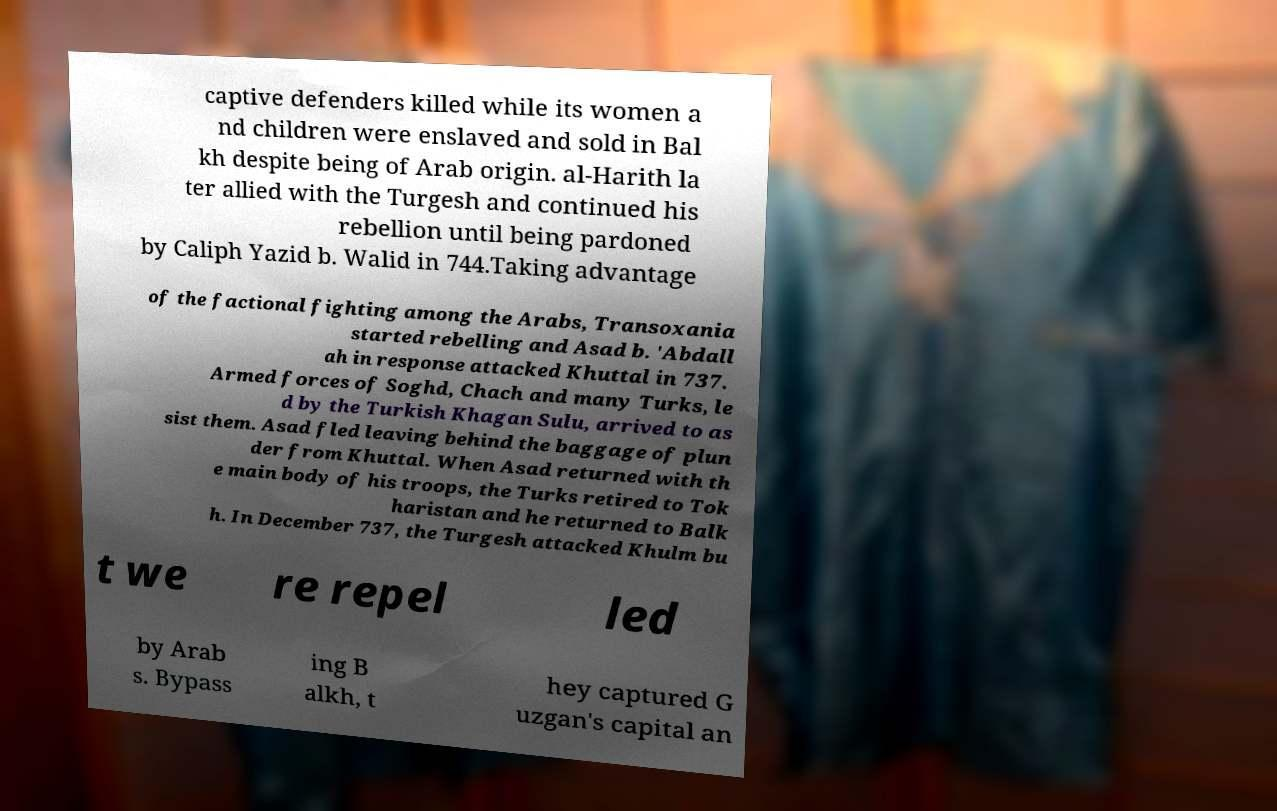There's text embedded in this image that I need extracted. Can you transcribe it verbatim? captive defenders killed while its women a nd children were enslaved and sold in Bal kh despite being of Arab origin. al-Harith la ter allied with the Turgesh and continued his rebellion until being pardoned by Caliph Yazid b. Walid in 744.Taking advantage of the factional fighting among the Arabs, Transoxania started rebelling and Asad b. 'Abdall ah in response attacked Khuttal in 737. Armed forces of Soghd, Chach and many Turks, le d by the Turkish Khagan Sulu, arrived to as sist them. Asad fled leaving behind the baggage of plun der from Khuttal. When Asad returned with th e main body of his troops, the Turks retired to Tok haristan and he returned to Balk h. In December 737, the Turgesh attacked Khulm bu t we re repel led by Arab s. Bypass ing B alkh, t hey captured G uzgan's capital an 